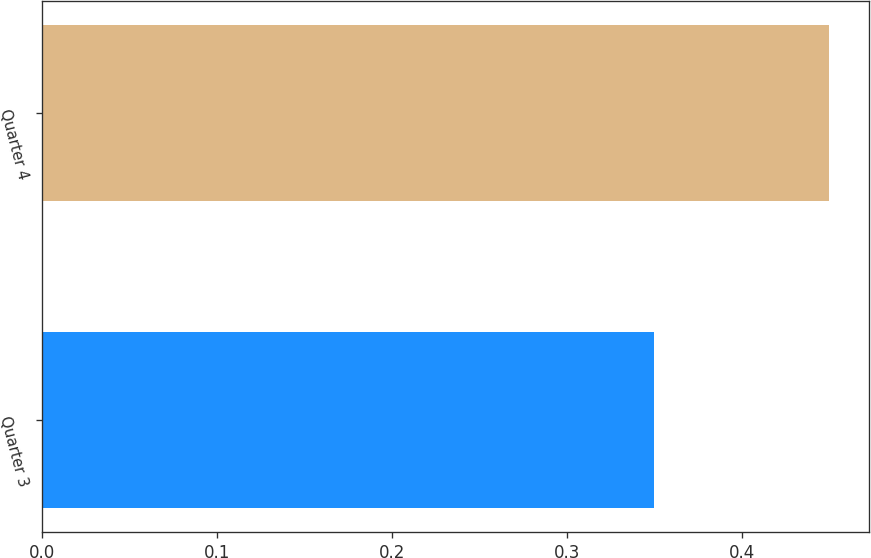Convert chart. <chart><loc_0><loc_0><loc_500><loc_500><bar_chart><fcel>Quarter 3<fcel>Quarter 4<nl><fcel>0.35<fcel>0.45<nl></chart> 